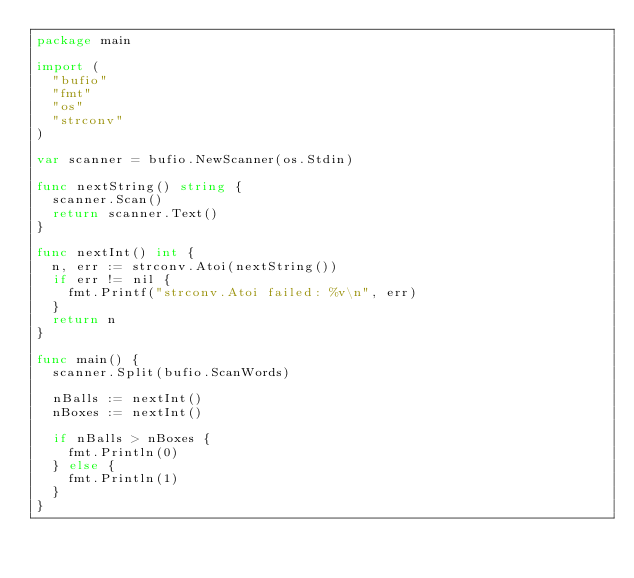<code> <loc_0><loc_0><loc_500><loc_500><_Go_>package main

import (
	"bufio"
	"fmt"
	"os"
	"strconv"
)

var scanner = bufio.NewScanner(os.Stdin)

func nextString() string {
	scanner.Scan()
	return scanner.Text()
}

func nextInt() int {
	n, err := strconv.Atoi(nextString())
	if err != nil {
		fmt.Printf("strconv.Atoi failed: %v\n", err)
	}
	return n
}

func main() {
	scanner.Split(bufio.ScanWords)

	nBalls := nextInt()
	nBoxes := nextInt()

	if nBalls > nBoxes {
		fmt.Println(0)
	} else {
		fmt.Println(1)
	}
}

</code> 